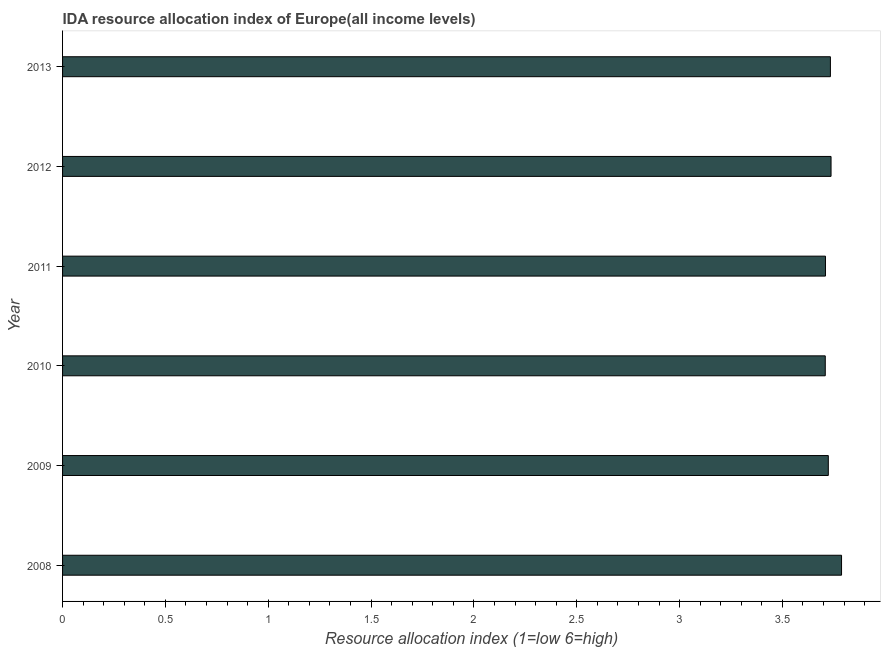What is the title of the graph?
Your response must be concise. IDA resource allocation index of Europe(all income levels). What is the label or title of the X-axis?
Ensure brevity in your answer.  Resource allocation index (1=low 6=high). What is the label or title of the Y-axis?
Provide a succinct answer. Year. What is the ida resource allocation index in 2013?
Make the answer very short. 3.73. Across all years, what is the maximum ida resource allocation index?
Provide a succinct answer. 3.79. Across all years, what is the minimum ida resource allocation index?
Provide a short and direct response. 3.71. In which year was the ida resource allocation index maximum?
Offer a very short reply. 2008. In which year was the ida resource allocation index minimum?
Provide a succinct answer. 2010. What is the sum of the ida resource allocation index?
Provide a short and direct response. 22.4. What is the difference between the ida resource allocation index in 2008 and 2011?
Your answer should be very brief. 0.08. What is the average ida resource allocation index per year?
Offer a terse response. 3.73. What is the median ida resource allocation index?
Give a very brief answer. 3.73. In how many years, is the ida resource allocation index greater than 0.1 ?
Your response must be concise. 6. Do a majority of the years between 2008 and 2013 (inclusive) have ida resource allocation index greater than 1 ?
Offer a very short reply. Yes. What is the ratio of the ida resource allocation index in 2008 to that in 2011?
Keep it short and to the point. 1.02. Is the difference between the ida resource allocation index in 2011 and 2012 greater than the difference between any two years?
Ensure brevity in your answer.  No. What is the difference between the highest and the second highest ida resource allocation index?
Ensure brevity in your answer.  0.05. Is the sum of the ida resource allocation index in 2010 and 2013 greater than the maximum ida resource allocation index across all years?
Keep it short and to the point. Yes. What is the difference between the highest and the lowest ida resource allocation index?
Offer a very short reply. 0.08. How many bars are there?
Make the answer very short. 6. What is the difference between two consecutive major ticks on the X-axis?
Keep it short and to the point. 0.5. Are the values on the major ticks of X-axis written in scientific E-notation?
Provide a succinct answer. No. What is the Resource allocation index (1=low 6=high) in 2008?
Your response must be concise. 3.79. What is the Resource allocation index (1=low 6=high) of 2009?
Provide a short and direct response. 3.72. What is the Resource allocation index (1=low 6=high) of 2010?
Your answer should be very brief. 3.71. What is the Resource allocation index (1=low 6=high) of 2011?
Give a very brief answer. 3.71. What is the Resource allocation index (1=low 6=high) in 2012?
Offer a very short reply. 3.74. What is the Resource allocation index (1=low 6=high) in 2013?
Your answer should be very brief. 3.73. What is the difference between the Resource allocation index (1=low 6=high) in 2008 and 2009?
Provide a succinct answer. 0.06. What is the difference between the Resource allocation index (1=low 6=high) in 2008 and 2010?
Give a very brief answer. 0.08. What is the difference between the Resource allocation index (1=low 6=high) in 2008 and 2011?
Offer a very short reply. 0.08. What is the difference between the Resource allocation index (1=low 6=high) in 2008 and 2012?
Ensure brevity in your answer.  0.05. What is the difference between the Resource allocation index (1=low 6=high) in 2008 and 2013?
Your response must be concise. 0.05. What is the difference between the Resource allocation index (1=low 6=high) in 2009 and 2010?
Provide a short and direct response. 0.01. What is the difference between the Resource allocation index (1=low 6=high) in 2009 and 2011?
Make the answer very short. 0.01. What is the difference between the Resource allocation index (1=low 6=high) in 2009 and 2012?
Your response must be concise. -0.01. What is the difference between the Resource allocation index (1=low 6=high) in 2009 and 2013?
Your response must be concise. -0.01. What is the difference between the Resource allocation index (1=low 6=high) in 2010 and 2011?
Make the answer very short. -0. What is the difference between the Resource allocation index (1=low 6=high) in 2010 and 2012?
Offer a terse response. -0.03. What is the difference between the Resource allocation index (1=low 6=high) in 2010 and 2013?
Offer a terse response. -0.03. What is the difference between the Resource allocation index (1=low 6=high) in 2011 and 2012?
Your answer should be compact. -0.03. What is the difference between the Resource allocation index (1=low 6=high) in 2011 and 2013?
Give a very brief answer. -0.02. What is the difference between the Resource allocation index (1=low 6=high) in 2012 and 2013?
Make the answer very short. 0. What is the ratio of the Resource allocation index (1=low 6=high) in 2008 to that in 2009?
Keep it short and to the point. 1.02. What is the ratio of the Resource allocation index (1=low 6=high) in 2008 to that in 2010?
Offer a terse response. 1.02. What is the ratio of the Resource allocation index (1=low 6=high) in 2008 to that in 2011?
Make the answer very short. 1.02. What is the ratio of the Resource allocation index (1=low 6=high) in 2009 to that in 2010?
Your answer should be very brief. 1. What is the ratio of the Resource allocation index (1=low 6=high) in 2009 to that in 2011?
Keep it short and to the point. 1. What is the ratio of the Resource allocation index (1=low 6=high) in 2009 to that in 2012?
Keep it short and to the point. 1. What is the ratio of the Resource allocation index (1=low 6=high) in 2009 to that in 2013?
Make the answer very short. 1. What is the ratio of the Resource allocation index (1=low 6=high) in 2010 to that in 2011?
Your response must be concise. 1. What is the ratio of the Resource allocation index (1=low 6=high) in 2010 to that in 2012?
Give a very brief answer. 0.99. What is the ratio of the Resource allocation index (1=low 6=high) in 2010 to that in 2013?
Your answer should be very brief. 0.99. What is the ratio of the Resource allocation index (1=low 6=high) in 2011 to that in 2012?
Give a very brief answer. 0.99. What is the ratio of the Resource allocation index (1=low 6=high) in 2011 to that in 2013?
Offer a very short reply. 0.99. What is the ratio of the Resource allocation index (1=low 6=high) in 2012 to that in 2013?
Ensure brevity in your answer.  1. 